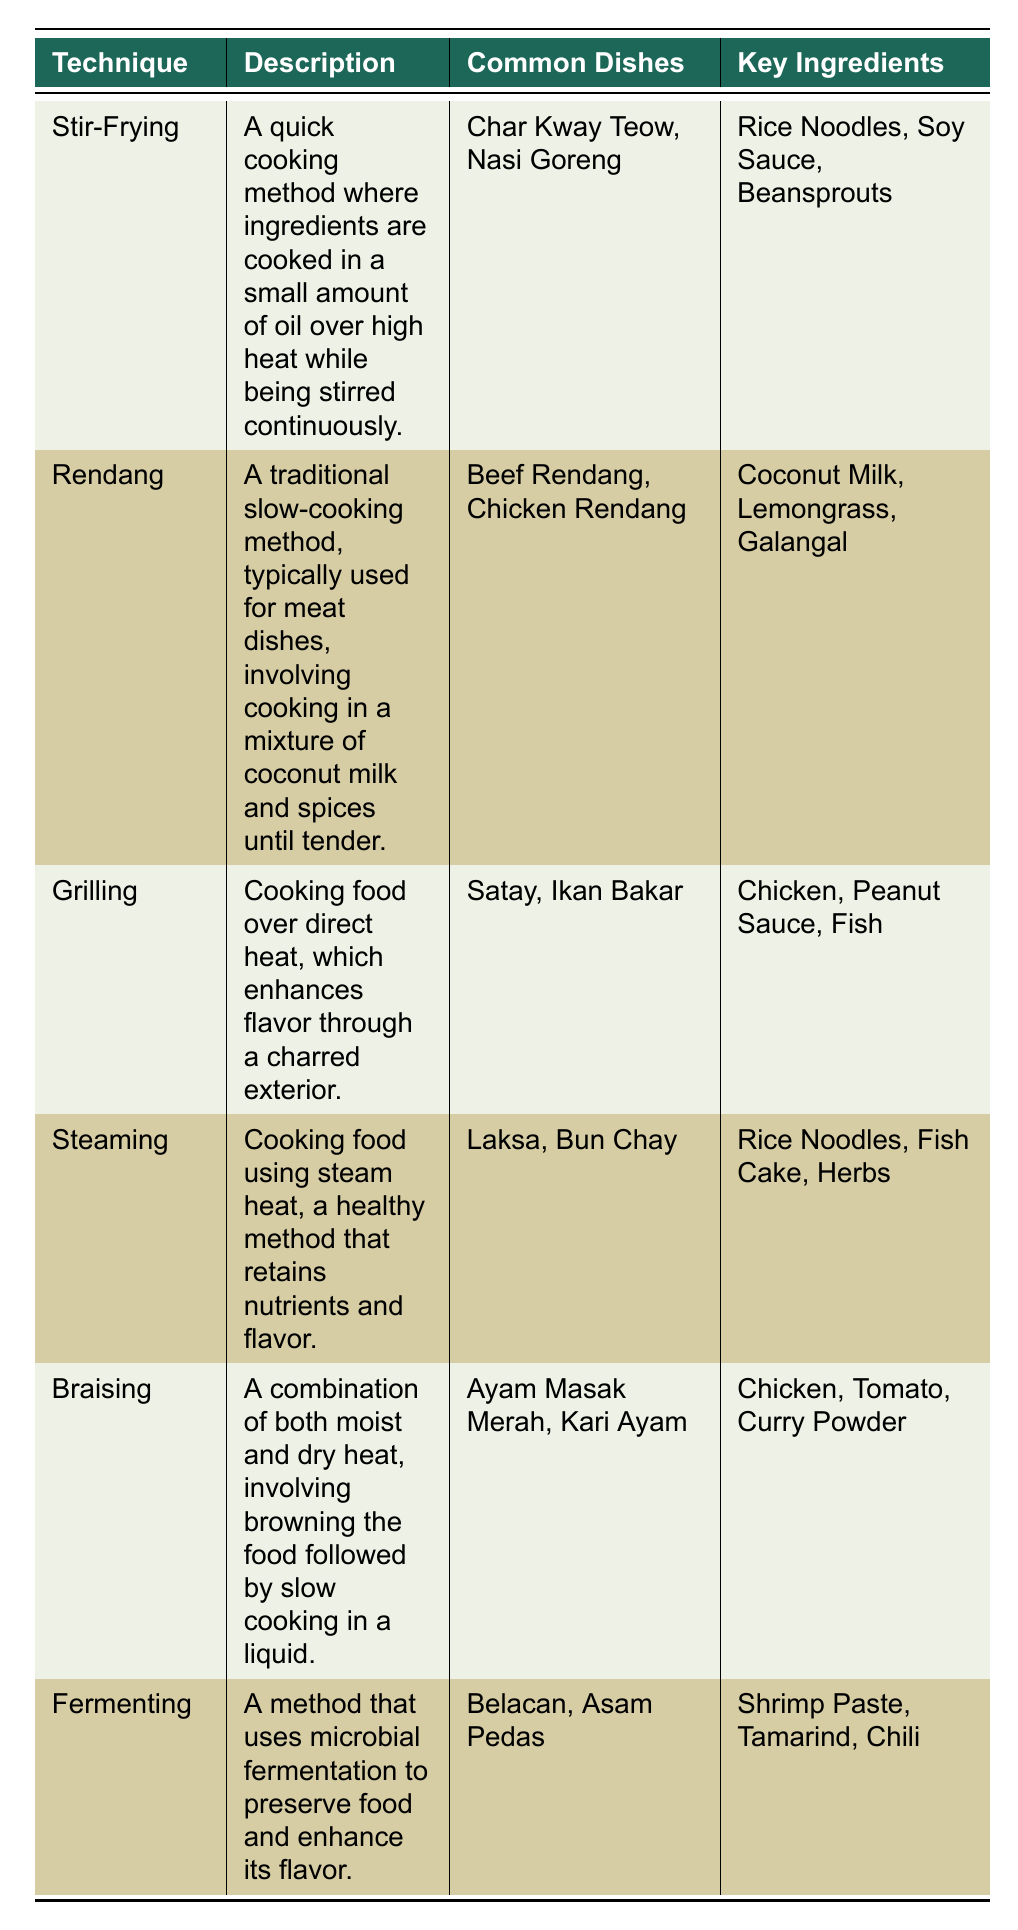What is the cooking technique that involves using a small amount of oil over high heat? The table shows that "Stir-Frying" is defined as a quick cooking method where ingredients are cooked in a small amount of oil over high heat while being stirred continuously.
Answer: Stir-Frying What common dish is made using the Fermenting technique? From the table, the common dishes listed under the Fermenting technique are "Belacan" and "Asam Pedas." Therefore, either of these dishes can serve as an answer.
Answer: Belacan (or Asam Pedas) Which key ingredient is used in both Grilling and Braising techniques? By examining the key ingredients for Grilling (Chicken, Peanut Sauce, Fish) and Braising (Chicken, Tomato, Curry Powder), we see that "Chicken" is common to both techniques.
Answer: Chicken Are Rice Noodles used in the Steaming cooking technique? Looking at the table, Rice Noodles are listed as a key ingredient for the Steaming technique, confirming the statement is true.
Answer: Yes What is the difference in cooking methods between Rendang and Stir-Frying? Rendang is a slow-cooking method involving coconut milk and spices until tender, while Stir-Frying is a quick method using high heat and small oil. This shows that Rendang requires more time and different cooking liquids than Stir-Frying.
Answer: Rendang is slow-cooking; Stir-Frying is quick cooking Which cooking technique is likely to preserve the most nutrients? The table indicates that Steaming is a method that retains nutrients and flavor due to its steam heat cooking process, suggesting it preserves more nutrients compared to other methods.
Answer: Steaming What is the sum of the common dishes for the Grilling and Braising techniques? Grilling has 2 common dishes (Satay, Ikan Bakar) and Braising has 2 common dishes (Ayam Masak Merah, Kari Ayam). Thus, the total is 2 + 2 = 4 common dishes when combined.
Answer: 4 Which cooking techniques are associated with slow cooking? Analyzing the table, both Rendang and Braising techniques are noted for their slow cooking methods. Thus, these are the techniques associated with slow cooking.
Answer: Rendang and Braising 